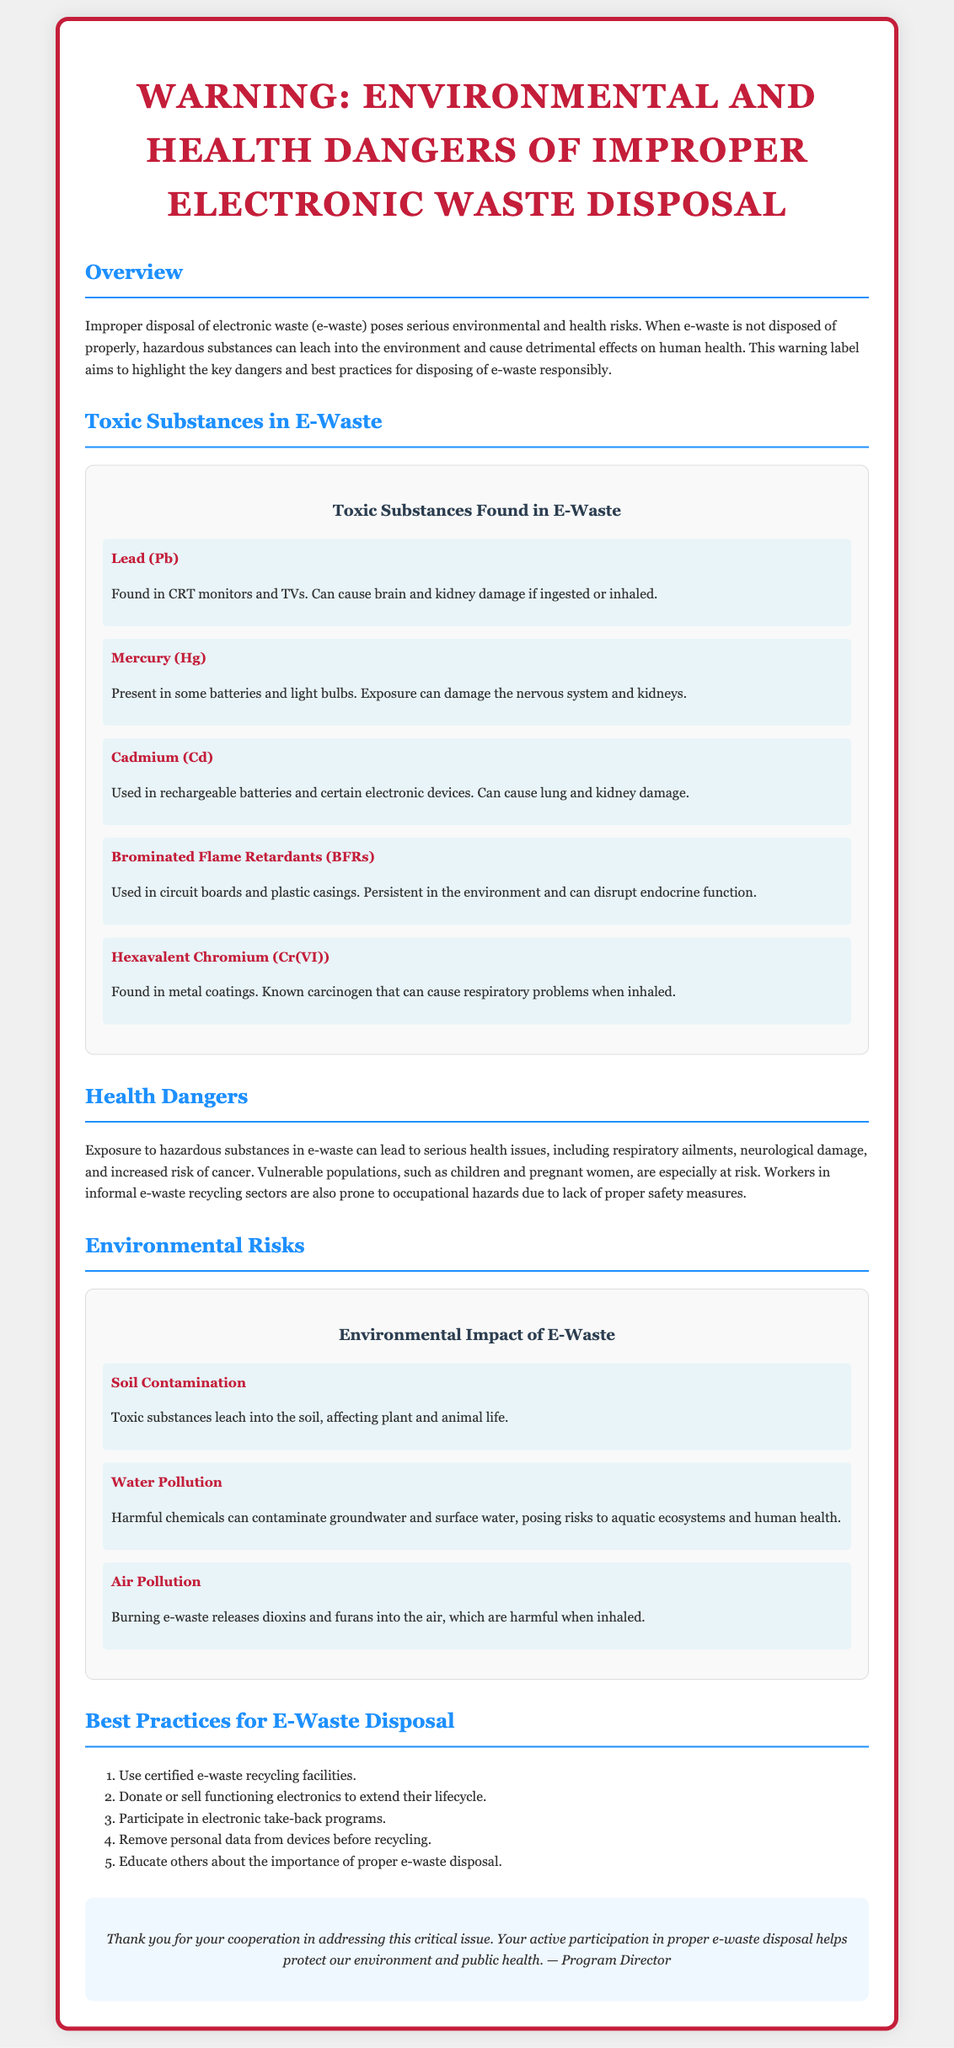What is the main topic of the warning label? The main topic of the warning label is the dangers related to the improper disposal of electronic waste.
Answer: Environmental and health dangers of improper electronic waste disposal How many toxic substances are listed in the document? The document lists five specific toxic substances found in e-waste.
Answer: Five What is the impact of lead in e-waste? The document states that lead can cause brain and kidney damage if ingested or inhaled.
Answer: Brain and kidney damage Which population is mentioned as especially at risk from exposure to e-waste? The document highlights that children and pregnant women are particularly vulnerable to the health risks associated with e-waste.
Answer: Children and pregnant women What is one best practice for e-waste disposal mentioned in the document? The document suggests using certified e-waste recycling facilities as a best practice for e-waste disposal.
Answer: Use certified e-waste recycling facilities Which substance is known as a carcinogen? The warning label indicates that hexavalent chromium is known to be a carcinogen.
Answer: Hexavalent Chromium What type of pollution can burning e-waste cause? The document states that burning e-waste releases harmful chemicals into the air.
Answer: Air Pollution What is a key consequence of soil contamination from e-waste? The document mentions that toxic substances can leach into the soil, affecting plant and animal life.
Answer: Affecting plant and animal life 